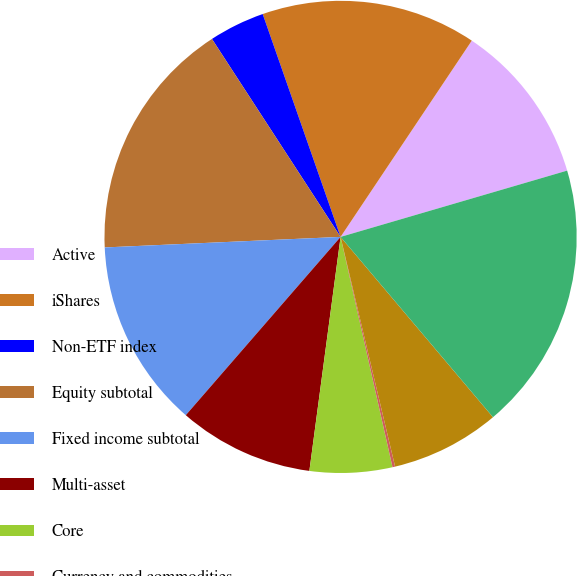Convert chart. <chart><loc_0><loc_0><loc_500><loc_500><pie_chart><fcel>Active<fcel>iShares<fcel>Non-ETF index<fcel>Equity subtotal<fcel>Fixed income subtotal<fcel>Multi-asset<fcel>Core<fcel>Currency and commodities<fcel>Alternatives subtotal<fcel>Long-term<nl><fcel>11.09%<fcel>14.73%<fcel>3.82%<fcel>16.54%<fcel>12.91%<fcel>9.27%<fcel>5.64%<fcel>0.18%<fcel>7.46%<fcel>18.36%<nl></chart> 